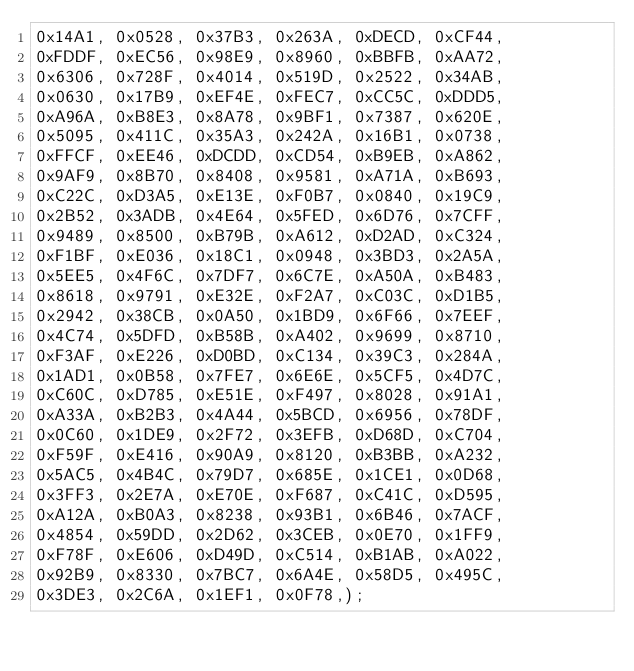<code> <loc_0><loc_0><loc_500><loc_500><_PHP_>0x14A1, 0x0528, 0x37B3, 0x263A, 0xDECD, 0xCF44,
0xFDDF, 0xEC56, 0x98E9, 0x8960, 0xBBFB, 0xAA72,
0x6306, 0x728F, 0x4014, 0x519D, 0x2522, 0x34AB,
0x0630, 0x17B9, 0xEF4E, 0xFEC7, 0xCC5C, 0xDDD5,
0xA96A, 0xB8E3, 0x8A78, 0x9BF1, 0x7387, 0x620E,
0x5095, 0x411C, 0x35A3, 0x242A, 0x16B1, 0x0738,
0xFFCF, 0xEE46, 0xDCDD, 0xCD54, 0xB9EB, 0xA862,
0x9AF9, 0x8B70, 0x8408, 0x9581, 0xA71A, 0xB693,
0xC22C, 0xD3A5, 0xE13E, 0xF0B7, 0x0840, 0x19C9,
0x2B52, 0x3ADB, 0x4E64, 0x5FED, 0x6D76, 0x7CFF,
0x9489, 0x8500, 0xB79B, 0xA612, 0xD2AD, 0xC324,
0xF1BF, 0xE036, 0x18C1, 0x0948, 0x3BD3, 0x2A5A,
0x5EE5, 0x4F6C, 0x7DF7, 0x6C7E, 0xA50A, 0xB483,
0x8618, 0x9791, 0xE32E, 0xF2A7, 0xC03C, 0xD1B5,
0x2942, 0x38CB, 0x0A50, 0x1BD9, 0x6F66, 0x7EEF,
0x4C74, 0x5DFD, 0xB58B, 0xA402, 0x9699, 0x8710,
0xF3AF, 0xE226, 0xD0BD, 0xC134, 0x39C3, 0x284A,
0x1AD1, 0x0B58, 0x7FE7, 0x6E6E, 0x5CF5, 0x4D7C,
0xC60C, 0xD785, 0xE51E, 0xF497, 0x8028, 0x91A1,
0xA33A, 0xB2B3, 0x4A44, 0x5BCD, 0x6956, 0x78DF,
0x0C60, 0x1DE9, 0x2F72, 0x3EFB, 0xD68D, 0xC704,
0xF59F, 0xE416, 0x90A9, 0x8120, 0xB3BB, 0xA232,
0x5AC5, 0x4B4C, 0x79D7, 0x685E, 0x1CE1, 0x0D68,
0x3FF3, 0x2E7A, 0xE70E, 0xF687, 0xC41C, 0xD595,
0xA12A, 0xB0A3, 0x8238, 0x93B1, 0x6B46, 0x7ACF,
0x4854, 0x59DD, 0x2D62, 0x3CEB, 0x0E70, 0x1FF9,
0xF78F, 0xE606, 0xD49D, 0xC514, 0xB1AB, 0xA022,
0x92B9, 0x8330, 0x7BC7, 0x6A4E, 0x58D5, 0x495C,
0x3DE3, 0x2C6A, 0x1EF1, 0x0F78,);

</code> 